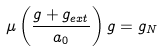Convert formula to latex. <formula><loc_0><loc_0><loc_500><loc_500>\mu \left ( \frac { g + g _ { e x t } } { a _ { 0 } } \right ) g = g _ { N }</formula> 